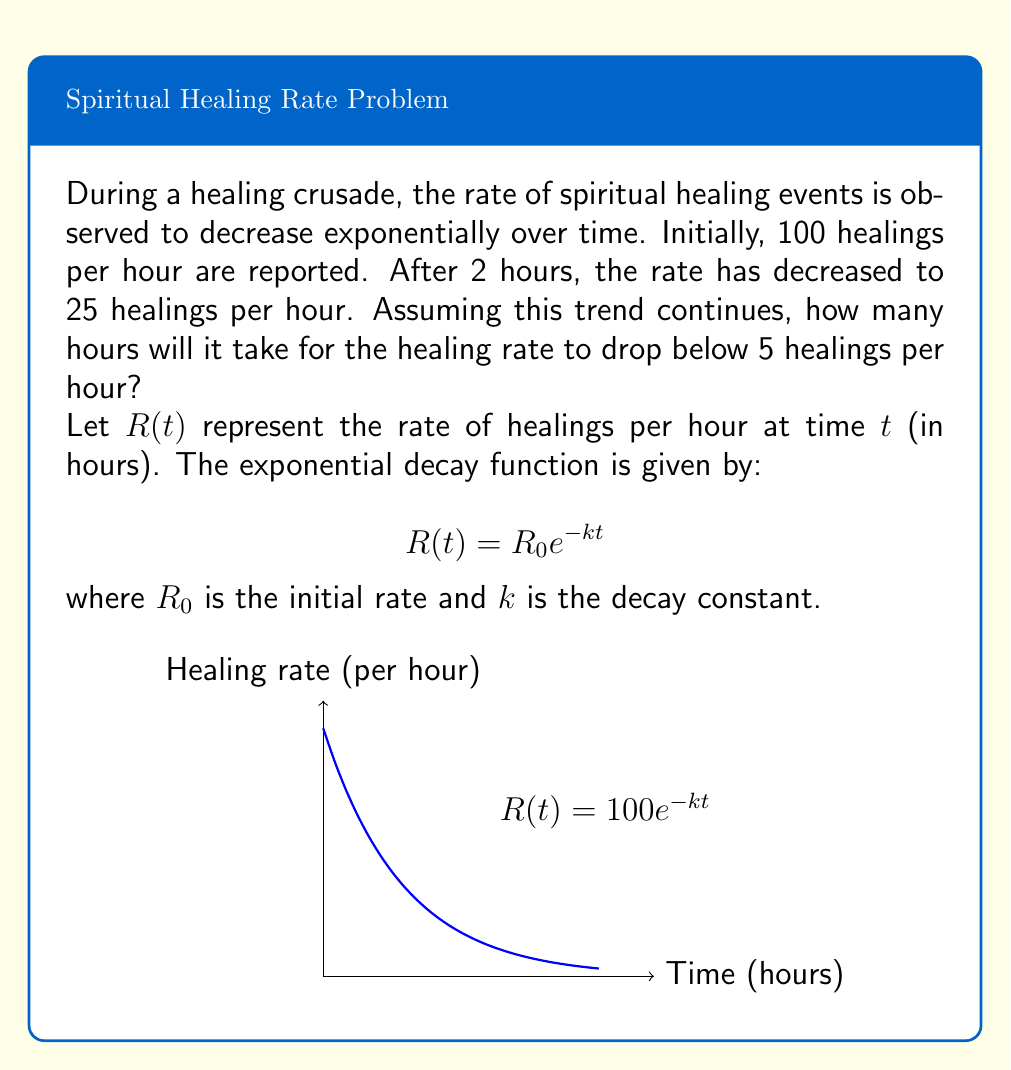Provide a solution to this math problem. To solve this problem, we'll follow these steps:

1) First, we need to find the decay constant $k$. We can use the given information:
   $R(0) = 100$ and $R(2) = 25$

2) Substituting into the exponential decay formula:
   $25 = 100e^{-2k}$

3) Solving for $k$:
   $\frac{1}{4} = e^{-2k}$
   $\ln(\frac{1}{4}) = -2k$
   $-\ln(4) = -2k$
   $k = \frac{\ln(4)}{2} \approx 0.693147$

4) Now that we have $k$, we can write the full equation:
   $R(t) = 100e^{-0.693147t}$

5) To find when the rate drops below 5, we solve:
   $5 = 100e^{-0.693147t}$

6) Solving for $t$:
   $\frac{1}{20} = e^{-0.693147t}$
   $\ln(\frac{1}{20}) = -0.693147t$
   $t = \frac{-\ln(\frac{1}{20})}{0.693147}$
   $t = \frac{\ln(20)}{0.693147} \approx 4.32$ hours

Therefore, it will take approximately 4.32 hours for the healing rate to drop below 5 per hour.
Answer: 4.32 hours 